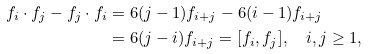<formula> <loc_0><loc_0><loc_500><loc_500>f _ { i } \cdot f _ { j } - f _ { j } \cdot f _ { i } & = 6 ( j - 1 ) f _ { i + j } - 6 ( i - 1 ) f _ { i + j } \\ & = 6 ( j - i ) f _ { i + j } = [ f _ { i } , f _ { j } ] , \quad i , j \geq 1 ,</formula> 